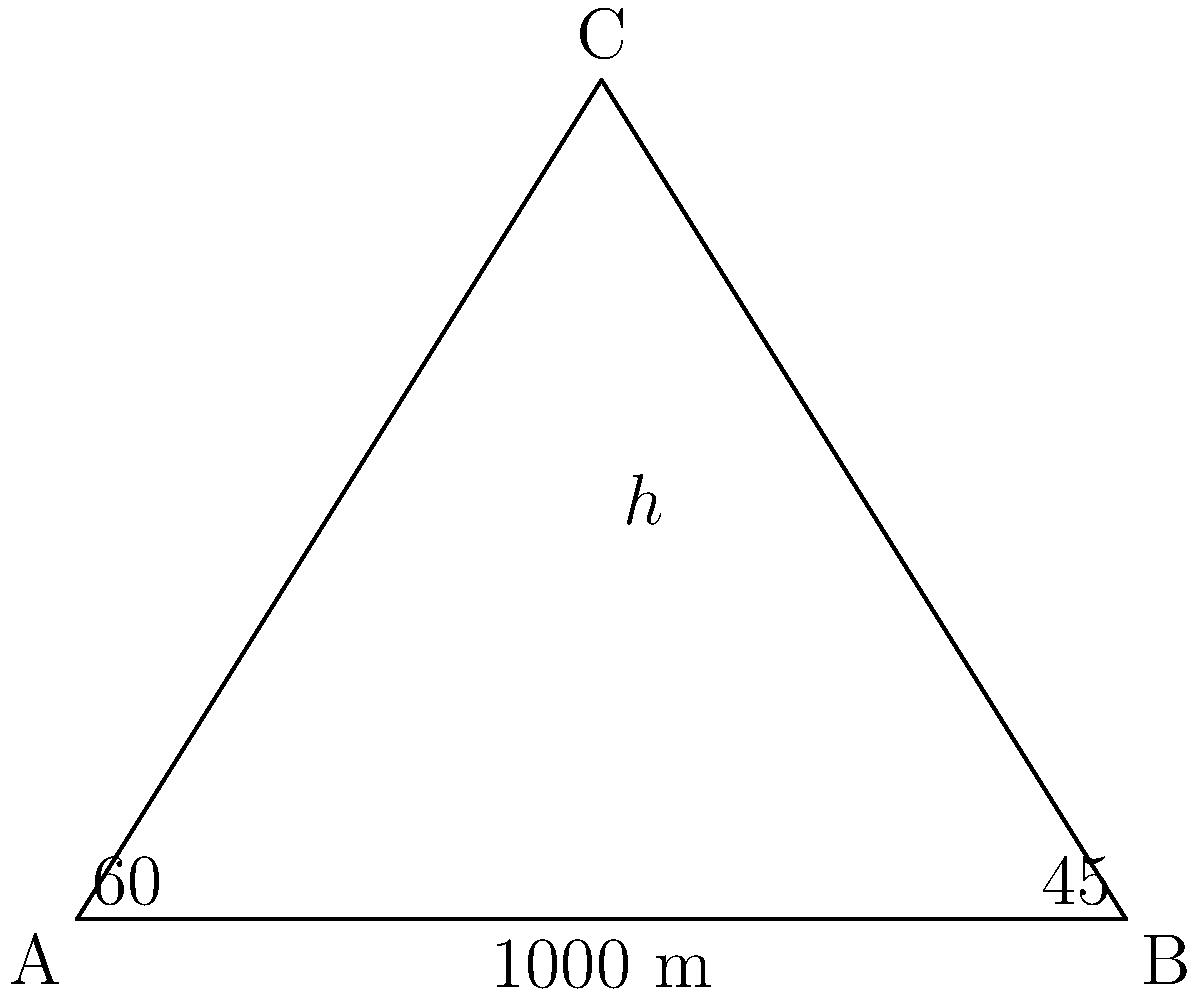From your observation point A, you measure the angle of elevation to the top of a smoke plume (point C) to be 60°. A colleague at point B, which is 1000 meters away from you on level ground, measures the angle of elevation to the same point to be 45°. What is the approximate height of the smoke plume in meters? Let's solve this step-by-step using trigonometry:

1) Let's define our variables:
   $h$ = height of the smoke plume
   $d$ = distance between observation points A and B (1000 m)

2) We can create two right triangles: ACD and BCD

3) For triangle ACD:
   $\tan 60° = \frac{h}{x}$, where $x$ is the distance from A to the point directly below C

4) For triangle BCD:
   $\tan 45° = \frac{h}{d-x}$

5) We know that $\tan 60° = \sqrt{3}$ and $\tan 45° = 1$

6) So we can write:
   $\sqrt{3} = \frac{h}{x}$ and $1 = \frac{h}{1000-x}$

7) From these, we can derive:
   $h = x\sqrt{3}$ and $h = 1000-x$

8) Setting these equal:
   $x\sqrt{3} = 1000-x$

9) Solving for $x$:
   $x(\sqrt{3}+1) = 1000$
   $x = \frac{1000}{\sqrt{3}+1} \approx 366.0$ m

10) Now we can find $h$:
    $h = 1000-x \approx 634.0$ m

Therefore, the height of the smoke plume is approximately 634 meters.
Answer: 634 meters 